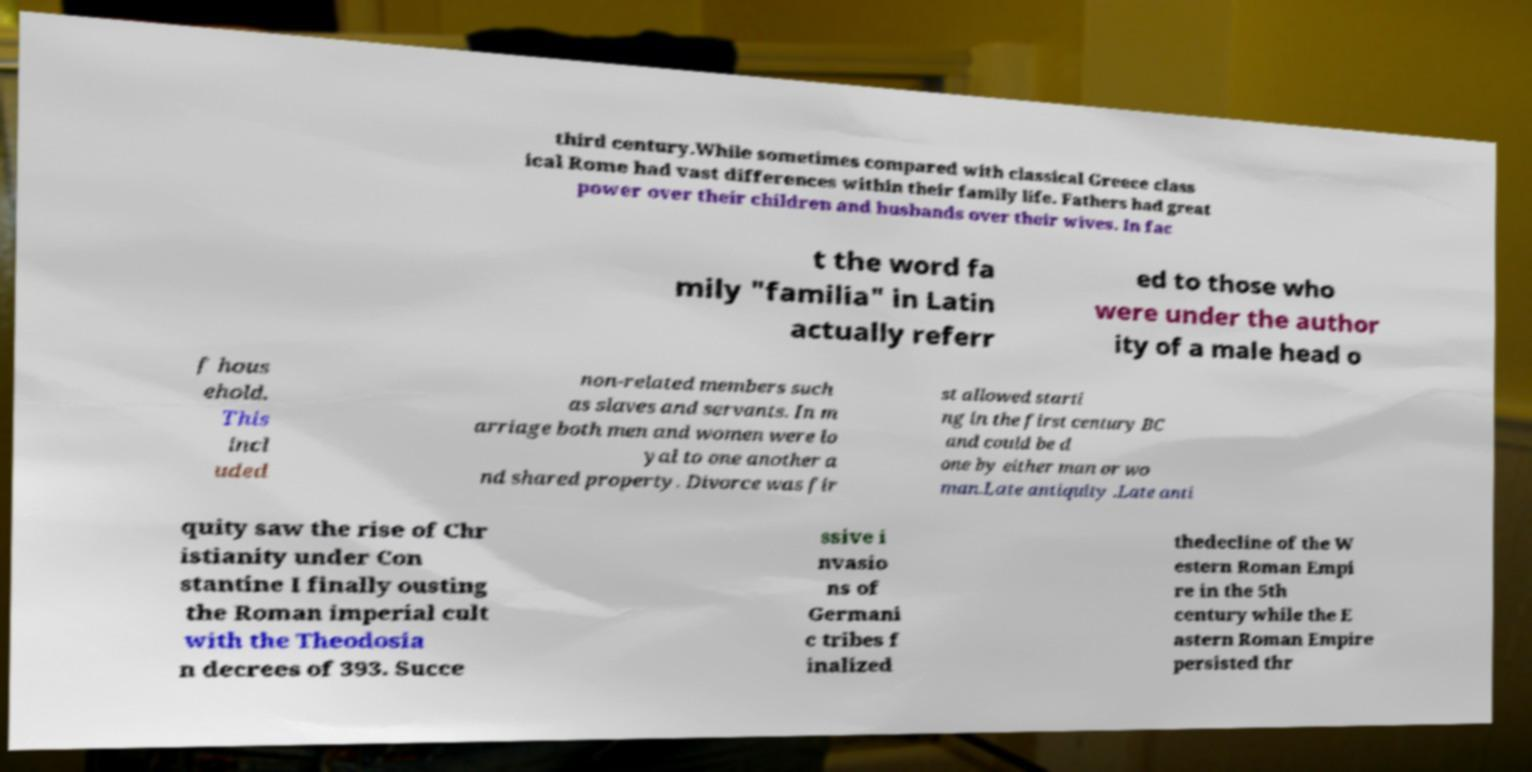Can you accurately transcribe the text from the provided image for me? third century.While sometimes compared with classical Greece class ical Rome had vast differences within their family life. Fathers had great power over their children and husbands over their wives. In fac t the word fa mily "familia" in Latin actually referr ed to those who were under the author ity of a male head o f hous ehold. This incl uded non-related members such as slaves and servants. In m arriage both men and women were lo yal to one another a nd shared property. Divorce was fir st allowed starti ng in the first century BC and could be d one by either man or wo man.Late antiquity .Late anti quity saw the rise of Chr istianity under Con stantine I finally ousting the Roman imperial cult with the Theodosia n decrees of 393. Succe ssive i nvasio ns of Germani c tribes f inalized thedecline of the W estern Roman Empi re in the 5th century while the E astern Roman Empire persisted thr 